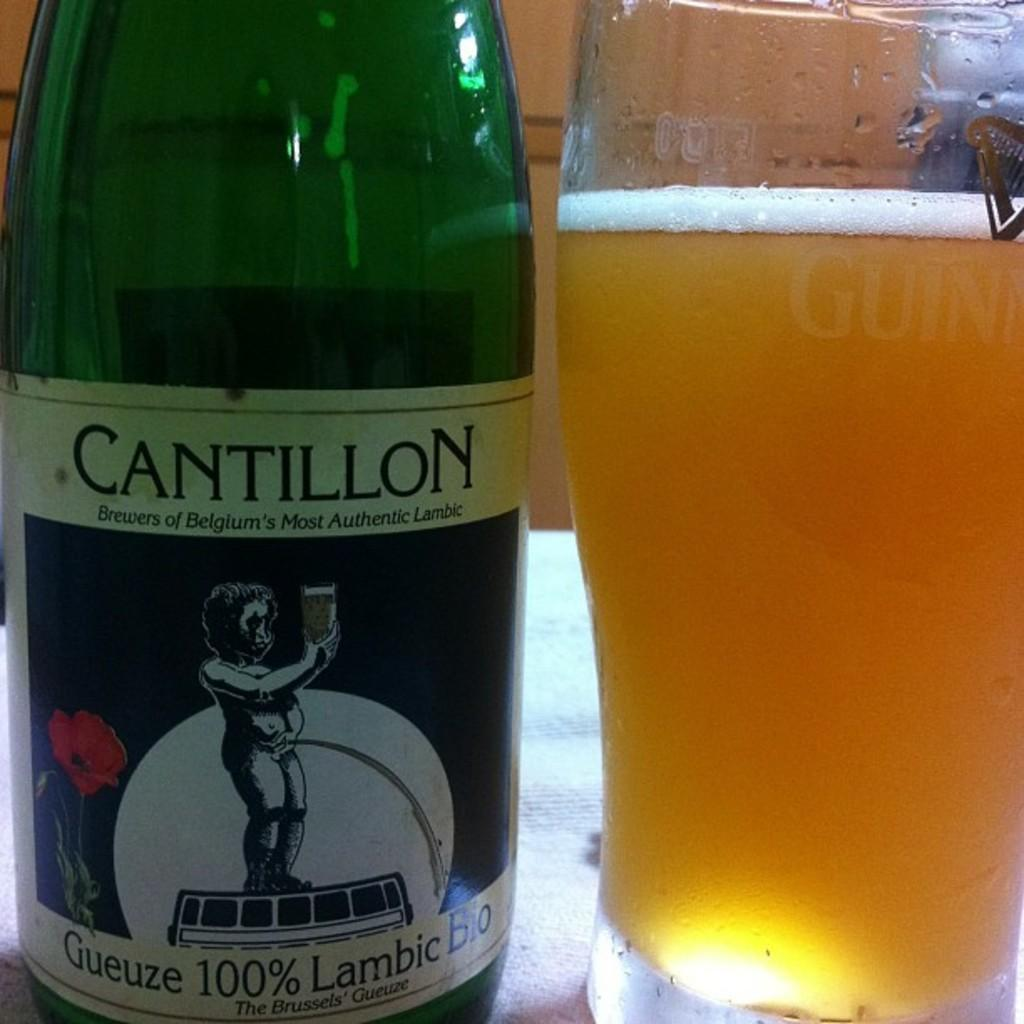<image>
Present a compact description of the photo's key features. A bottle Cantillon Lambic from Brussels sits next to a filled glass 